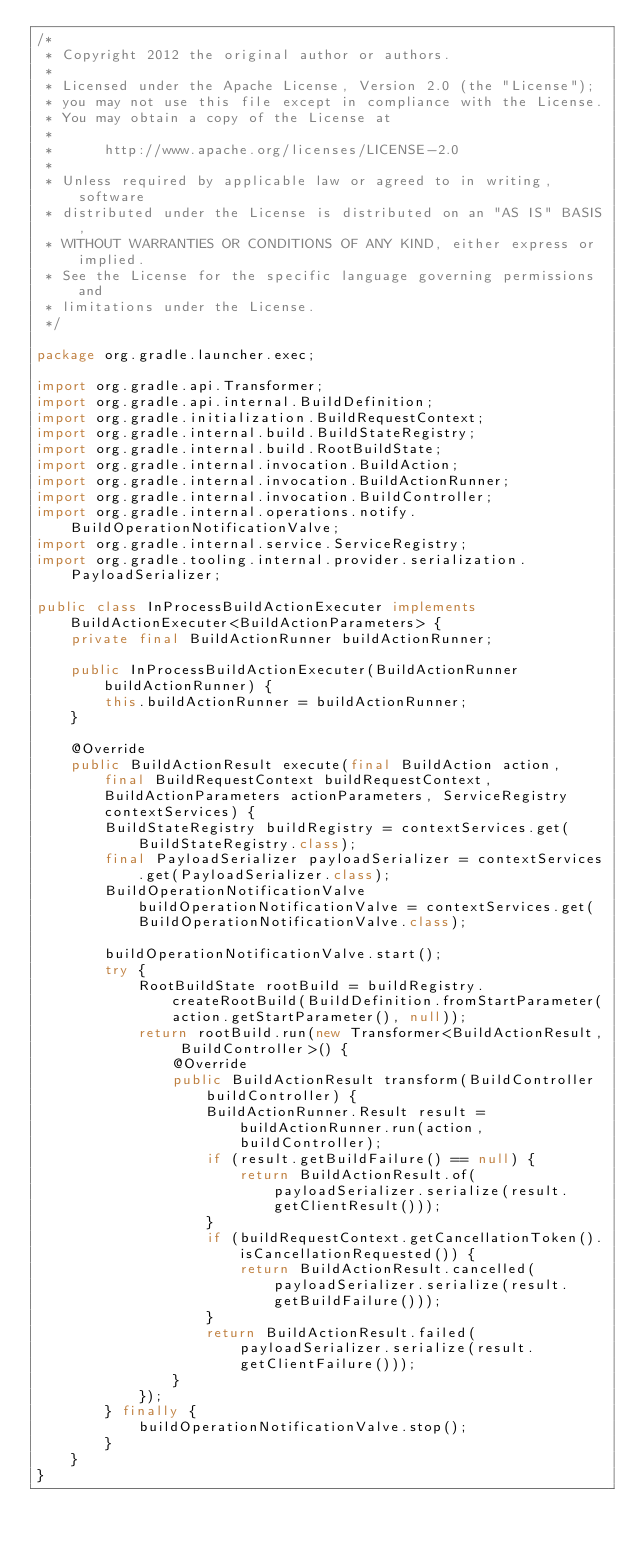<code> <loc_0><loc_0><loc_500><loc_500><_Java_>/*
 * Copyright 2012 the original author or authors.
 *
 * Licensed under the Apache License, Version 2.0 (the "License");
 * you may not use this file except in compliance with the License.
 * You may obtain a copy of the License at
 *
 *      http://www.apache.org/licenses/LICENSE-2.0
 *
 * Unless required by applicable law or agreed to in writing, software
 * distributed under the License is distributed on an "AS IS" BASIS,
 * WITHOUT WARRANTIES OR CONDITIONS OF ANY KIND, either express or implied.
 * See the License for the specific language governing permissions and
 * limitations under the License.
 */

package org.gradle.launcher.exec;

import org.gradle.api.Transformer;
import org.gradle.api.internal.BuildDefinition;
import org.gradle.initialization.BuildRequestContext;
import org.gradle.internal.build.BuildStateRegistry;
import org.gradle.internal.build.RootBuildState;
import org.gradle.internal.invocation.BuildAction;
import org.gradle.internal.invocation.BuildActionRunner;
import org.gradle.internal.invocation.BuildController;
import org.gradle.internal.operations.notify.BuildOperationNotificationValve;
import org.gradle.internal.service.ServiceRegistry;
import org.gradle.tooling.internal.provider.serialization.PayloadSerializer;

public class InProcessBuildActionExecuter implements BuildActionExecuter<BuildActionParameters> {
    private final BuildActionRunner buildActionRunner;

    public InProcessBuildActionExecuter(BuildActionRunner buildActionRunner) {
        this.buildActionRunner = buildActionRunner;
    }

    @Override
    public BuildActionResult execute(final BuildAction action, final BuildRequestContext buildRequestContext, BuildActionParameters actionParameters, ServiceRegistry contextServices) {
        BuildStateRegistry buildRegistry = contextServices.get(BuildStateRegistry.class);
        final PayloadSerializer payloadSerializer = contextServices.get(PayloadSerializer.class);
        BuildOperationNotificationValve buildOperationNotificationValve = contextServices.get(BuildOperationNotificationValve.class);

        buildOperationNotificationValve.start();
        try {
            RootBuildState rootBuild = buildRegistry.createRootBuild(BuildDefinition.fromStartParameter(action.getStartParameter(), null));
            return rootBuild.run(new Transformer<BuildActionResult, BuildController>() {
                @Override
                public BuildActionResult transform(BuildController buildController) {
                    BuildActionRunner.Result result = buildActionRunner.run(action, buildController);
                    if (result.getBuildFailure() == null) {
                        return BuildActionResult.of(payloadSerializer.serialize(result.getClientResult()));
                    }
                    if (buildRequestContext.getCancellationToken().isCancellationRequested()) {
                        return BuildActionResult.cancelled(payloadSerializer.serialize(result.getBuildFailure()));
                    }
                    return BuildActionResult.failed(payloadSerializer.serialize(result.getClientFailure()));
                }
            });
        } finally {
            buildOperationNotificationValve.stop();
        }
    }
}
</code> 